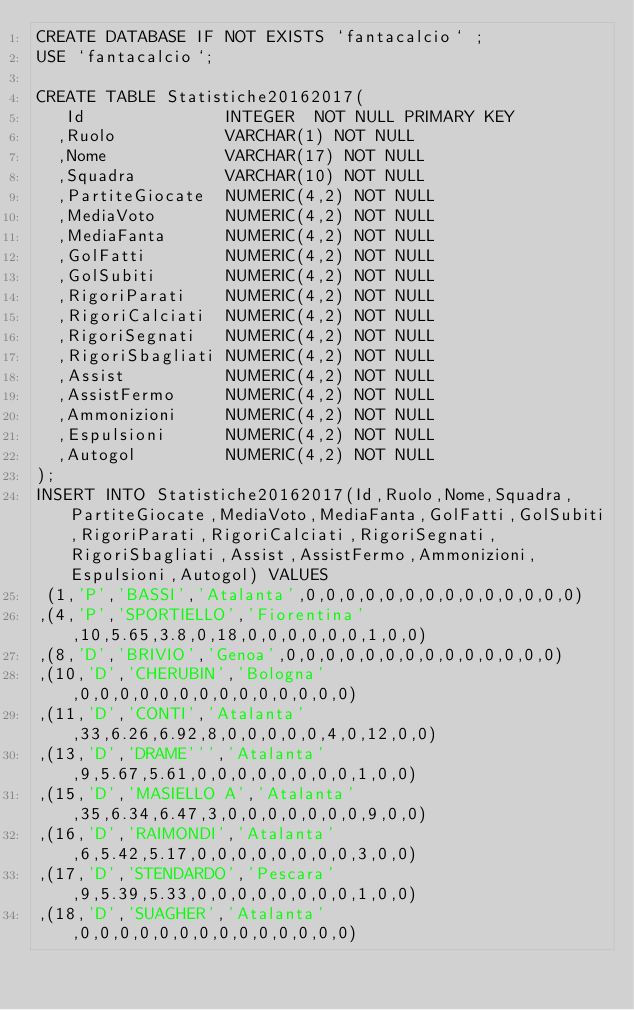<code> <loc_0><loc_0><loc_500><loc_500><_SQL_>CREATE DATABASE IF NOT EXISTS `fantacalcio` ;
USE `fantacalcio`;

CREATE TABLE Statistiche20162017(
   Id              INTEGER  NOT NULL PRIMARY KEY 
  ,Ruolo           VARCHAR(1) NOT NULL
  ,Nome            VARCHAR(17) NOT NULL
  ,Squadra         VARCHAR(10) NOT NULL
  ,PartiteGiocate  NUMERIC(4,2) NOT NULL
  ,MediaVoto       NUMERIC(4,2) NOT NULL
  ,MediaFanta      NUMERIC(4,2) NOT NULL
  ,GolFatti        NUMERIC(4,2) NOT NULL
  ,GolSubiti       NUMERIC(4,2) NOT NULL
  ,RigoriParati    NUMERIC(4,2) NOT NULL
  ,RigoriCalciati  NUMERIC(4,2) NOT NULL
  ,RigoriSegnati   NUMERIC(4,2) NOT NULL
  ,RigoriSbagliati NUMERIC(4,2) NOT NULL
  ,Assist          NUMERIC(4,2) NOT NULL
  ,AssistFermo     NUMERIC(4,2) NOT NULL
  ,Ammonizioni     NUMERIC(4,2) NOT NULL
  ,Espulsioni      NUMERIC(4,2) NOT NULL
  ,Autogol         NUMERIC(4,2) NOT NULL
);
INSERT INTO Statistiche20162017(Id,Ruolo,Nome,Squadra,PartiteGiocate,MediaVoto,MediaFanta,GolFatti,GolSubiti,RigoriParati,RigoriCalciati,RigoriSegnati,RigoriSbagliati,Assist,AssistFermo,Ammonizioni,Espulsioni,Autogol) VALUES
 (1,'P','BASSI','Atalanta',0,0,0,0,0,0,0,0,0,0,0,0,0,0)
,(4,'P','SPORTIELLO','Fiorentina',10,5.65,3.8,0,18,0,0,0,0,0,0,1,0,0)
,(8,'D','BRIVIO','Genoa',0,0,0,0,0,0,0,0,0,0,0,0,0,0)
,(10,'D','CHERUBIN','Bologna',0,0,0,0,0,0,0,0,0,0,0,0,0,0)
,(11,'D','CONTI','Atalanta',33,6.26,6.92,8,0,0,0,0,0,4,0,12,0,0)
,(13,'D','DRAME''','Atalanta',9,5.67,5.61,0,0,0,0,0,0,0,0,1,0,0)
,(15,'D','MASIELLO A','Atalanta',35,6.34,6.47,3,0,0,0,0,0,0,0,9,0,0)
,(16,'D','RAIMONDI','Atalanta',6,5.42,5.17,0,0,0,0,0,0,0,0,3,0,0)
,(17,'D','STENDARDO','Pescara',9,5.39,5.33,0,0,0,0,0,0,0,0,1,0,0)
,(18,'D','SUAGHER','Atalanta',0,0,0,0,0,0,0,0,0,0,0,0,0,0)</code> 